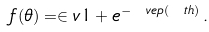Convert formula to latex. <formula><loc_0><loc_0><loc_500><loc_500>f ( \theta ) = \in v { 1 + e ^ { - \ v e p ( \ t h ) } } \, .</formula> 